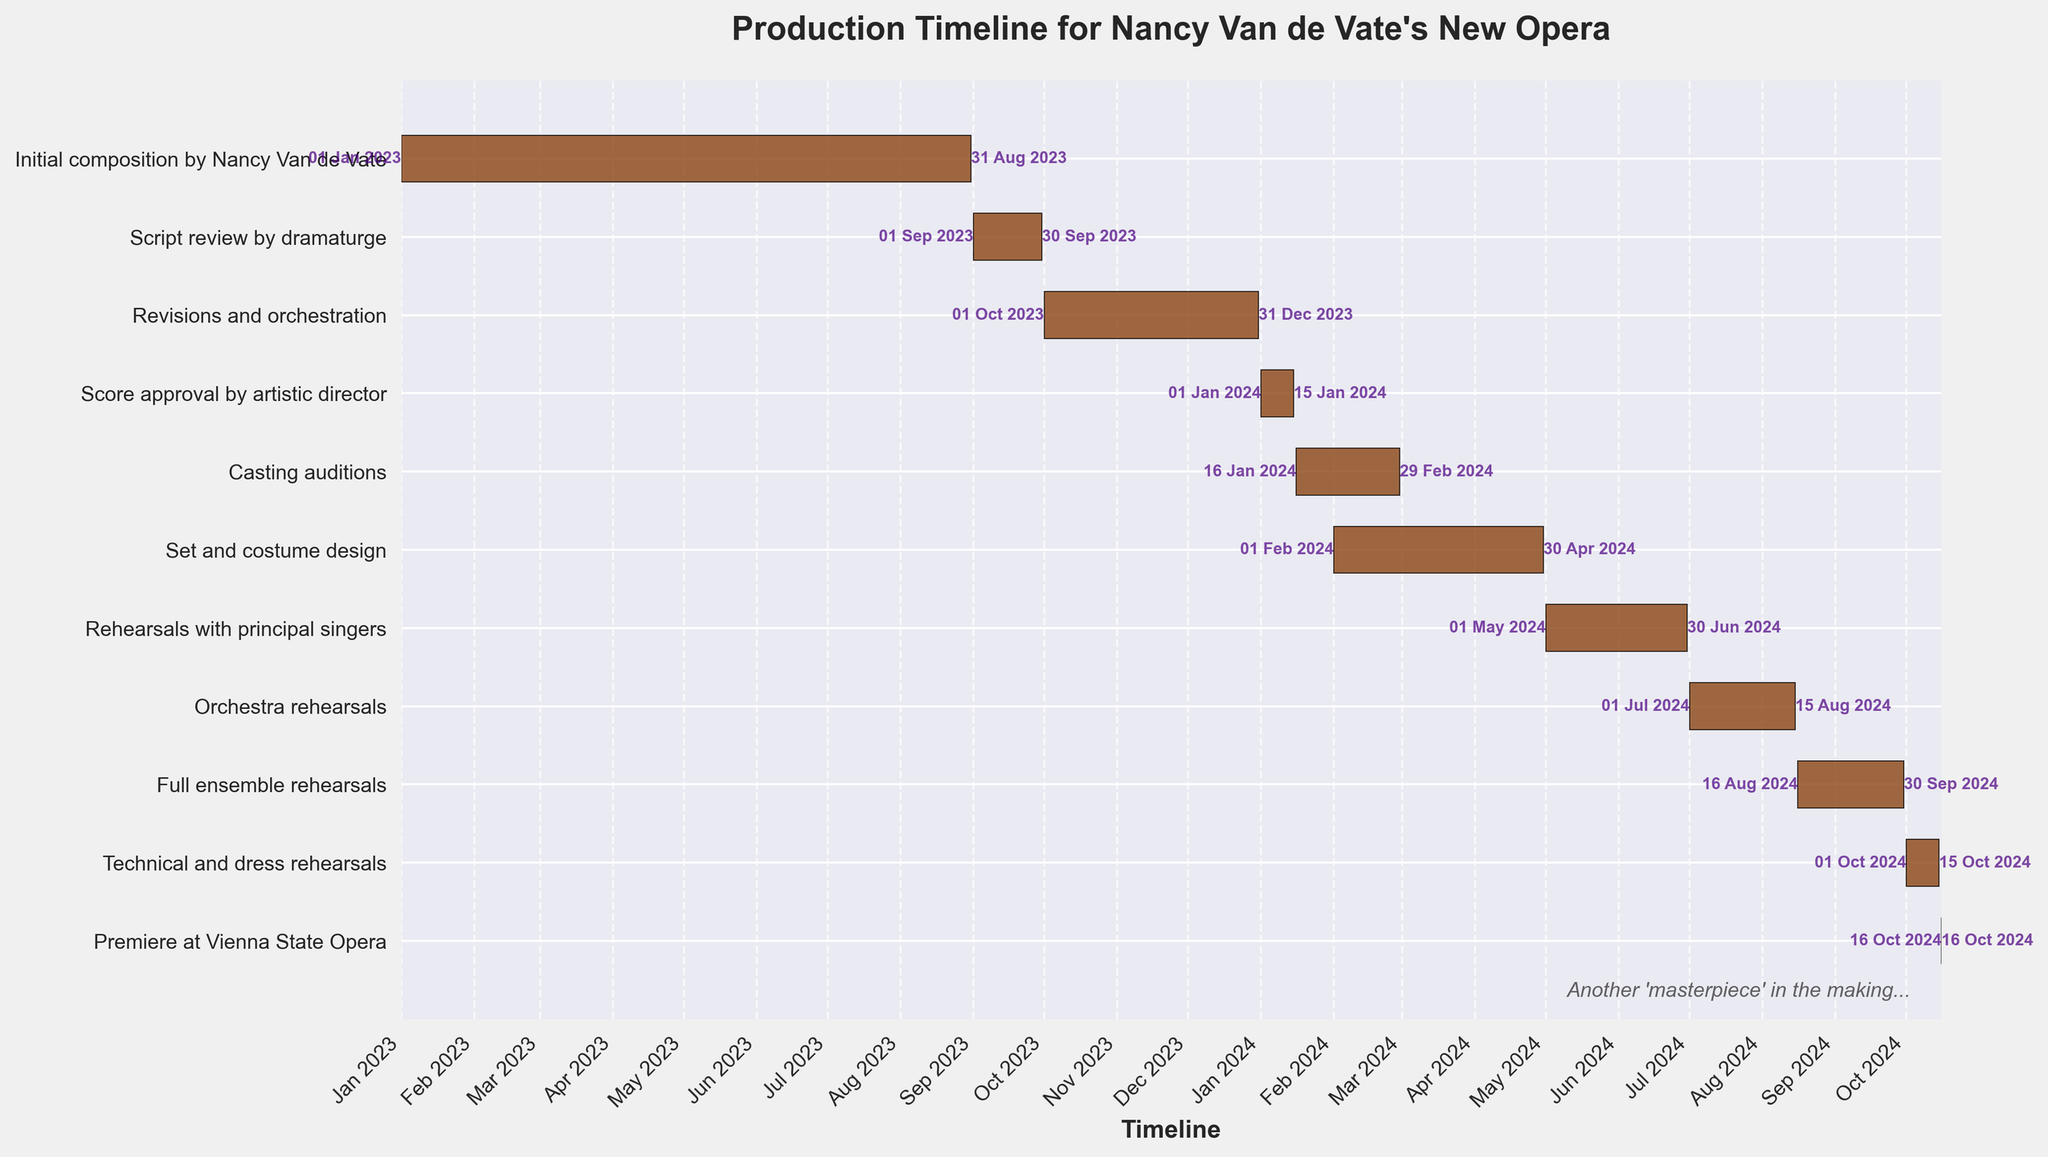What's the title of the figure? The title of the figure is usually found at the top of the chart and is designed to provide an overview of the subject of the chart. Looking at the figure
Answer: Production Timeline for Nancy Van de Vate's New Opera What does the darker color represent in the Gantt chart? In Gantt charts, colors often represent the bars for each task. In this case, the bars are dark brown, which are the visual representation of the duration of each task.
Answer: Duration of each task Which task has the longest duration and how long is it? To find the task with the longest duration, observe the horizontal length of each bar. The longest bar will represent the longest duration, which is the task "Initial composition by Nancy Van de Vate." The start date is January 1, 2023, and the end date is August 31, 2023.
Answer: Initial composition by Nancy Van de Vate, 8 months Compare the duration of 'Rehearsals with principal singers' and 'Orchestra rehearsals'. Which one is longer? First, identify the two tasks on the y-axis, and assess the length of the bars horizontally. "Rehearsals with principal singers" starts on May 1, 2024, and ends on June 30, 2024 (2 months). "Orchestra rehearsals" starts on July 1, 2024, and ends on August 15, 2024 (1.5 months).
Answer: Rehearsals with principal singers What is the first task that overlaps with 'Casting auditions'? To find tasks that overlap, compare the start and end dates of 'Casting auditions' (January 16, 2024, to February 29, 2024). The overlapping task would be 'Set and costume design', which starts on February 1, 2024.
Answer: Set and costume design By how many days do 'Technical and dress rehearsals' and 'Premiere at Vienna State Opera' differ? 'Technical and dress rehearsals' end on October 15, 2024, and the 'Premiere at Vienna State Opera' is on October 16, 2024. Calculate the difference in days between the two dates, which is 1 day.
Answer: 1 day What percentage of the total timeline is spent on 'Rehearsals with principal singers'? To calculate the percentage, determine the duration of 'Rehearsals with principal singers' (2 months) and the total timeline. The timeline starts on January 1, 2023, and ends on October 16, 2024, which totals approximately 21.5 months. Therefore, (2/21.5) * 100 = 9.3%.
Answer: 9.3% Which task directly follows 'Script review by dramaturge'? Identify 'Script review by dramaturge' on the y-axis, and see which task immediately starts after it finishes. 'Script review by dramaturge' ends on September 30, 2023, and 'Revisions and orchestration' starts on October 1, 2023.
Answer: Revisions and orchestration What's the total number of tasks depicted in the Gantt Chart? Count the number of distinct tasks listed on the y-axis. These are all the tasks included in the Gantt Chart.
Answer: 11 